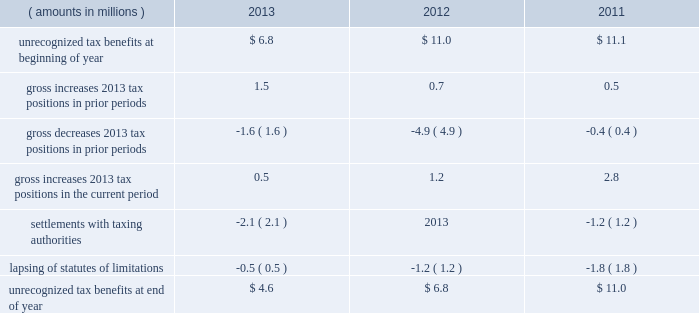A valuation allowance totaling $ 45.4 million , $ 43.9 million and $ 40.4 million as of 2013 , 2012 and 2011 year end , respectively , has been established for deferred income tax assets primarily related to certain subsidiary loss carryforwards that may not be realized .
Realization of the net deferred income tax assets is dependent on generating sufficient taxable income prior to their expiration .
Although realization is not assured , management believes it is more- likely-than-not that the net deferred income tax assets will be realized .
The amount of the net deferred income tax assets considered realizable , however , could change in the near term if estimates of future taxable income during the carryforward period fluctuate .
The following is a reconciliation of the beginning and ending amounts of unrecognized tax benefits for 2013 , 2012 and ( amounts in millions ) 2013 2012 2011 .
Of the $ 4.6 million , $ 6.8 million and $ 11.0 million of unrecognized tax benefits as of 2013 , 2012 and 2011 year end , respectively , approximately $ 4.6 million , $ 4.1 million and $ 9.1 million , respectively , would impact the effective income tax rate if recognized .
Interest and penalties related to unrecognized tax benefits are recorded in income tax expense .
During 2013 and 2012 , the company reversed a net $ 0.6 million and $ 0.5 million , respectively , of interest and penalties to income associated with unrecognized tax benefits .
As of 2013 , 2012 and 2011 year end , the company has provided for $ 0.9 million , $ 1.6 million and $ 1.6 million , respectively , of accrued interest and penalties related to unrecognized tax benefits .
The unrecognized tax benefits and related accrued interest and penalties are included in 201cother long-term liabilities 201d on the accompanying consolidated balance sheets .
Snap-on and its subsidiaries file income tax returns in the united states and in various state , local and foreign jurisdictions .
It is reasonably possible that certain unrecognized tax benefits may either be settled with taxing authorities or the statutes of limitations for such items may lapse within the next 12 months , causing snap-on 2019s gross unrecognized tax benefits to decrease by a range of zero to $ 1.1 million .
Over the next 12 months , snap-on anticipates taking certain tax positions on various tax returns for which the related tax benefit does not meet the recognition threshold .
Accordingly , snap-on 2019s gross unrecognized tax benefits may increase by a range of zero to $ 0.8 million over the next 12 months for uncertain tax positions expected to be taken in future tax filings .
With few exceptions , snap-on is no longer subject to u.s .
Federal and state/local income tax examinations by tax authorities for years prior to 2008 , and snap-on is no longer subject to non-u.s .
Income tax examinations by tax authorities for years prior to 2006 .
The undistributed earnings of all non-u.s .
Subsidiaries totaled $ 556.0 million , $ 492.2 million and $ 416.4 million as of 2013 , 2012 and 2011 year end , respectively .
Snap-on has not provided any deferred taxes on these undistributed earnings as it considers the undistributed earnings to be permanently invested .
Determination of the amount of unrecognized deferred income tax liability related to these earnings is not practicable .
2013 annual report 83 .
What is the net change amount in the unrecognized tax benefits during 2012? 
Computations: (6.8 - 11.0)
Answer: -4.2. A valuation allowance totaling $ 45.4 million , $ 43.9 million and $ 40.4 million as of 2013 , 2012 and 2011 year end , respectively , has been established for deferred income tax assets primarily related to certain subsidiary loss carryforwards that may not be realized .
Realization of the net deferred income tax assets is dependent on generating sufficient taxable income prior to their expiration .
Although realization is not assured , management believes it is more- likely-than-not that the net deferred income tax assets will be realized .
The amount of the net deferred income tax assets considered realizable , however , could change in the near term if estimates of future taxable income during the carryforward period fluctuate .
The following is a reconciliation of the beginning and ending amounts of unrecognized tax benefits for 2013 , 2012 and ( amounts in millions ) 2013 2012 2011 .
Of the $ 4.6 million , $ 6.8 million and $ 11.0 million of unrecognized tax benefits as of 2013 , 2012 and 2011 year end , respectively , approximately $ 4.6 million , $ 4.1 million and $ 9.1 million , respectively , would impact the effective income tax rate if recognized .
Interest and penalties related to unrecognized tax benefits are recorded in income tax expense .
During 2013 and 2012 , the company reversed a net $ 0.6 million and $ 0.5 million , respectively , of interest and penalties to income associated with unrecognized tax benefits .
As of 2013 , 2012 and 2011 year end , the company has provided for $ 0.9 million , $ 1.6 million and $ 1.6 million , respectively , of accrued interest and penalties related to unrecognized tax benefits .
The unrecognized tax benefits and related accrued interest and penalties are included in 201cother long-term liabilities 201d on the accompanying consolidated balance sheets .
Snap-on and its subsidiaries file income tax returns in the united states and in various state , local and foreign jurisdictions .
It is reasonably possible that certain unrecognized tax benefits may either be settled with taxing authorities or the statutes of limitations for such items may lapse within the next 12 months , causing snap-on 2019s gross unrecognized tax benefits to decrease by a range of zero to $ 1.1 million .
Over the next 12 months , snap-on anticipates taking certain tax positions on various tax returns for which the related tax benefit does not meet the recognition threshold .
Accordingly , snap-on 2019s gross unrecognized tax benefits may increase by a range of zero to $ 0.8 million over the next 12 months for uncertain tax positions expected to be taken in future tax filings .
With few exceptions , snap-on is no longer subject to u.s .
Federal and state/local income tax examinations by tax authorities for years prior to 2008 , and snap-on is no longer subject to non-u.s .
Income tax examinations by tax authorities for years prior to 2006 .
The undistributed earnings of all non-u.s .
Subsidiaries totaled $ 556.0 million , $ 492.2 million and $ 416.4 million as of 2013 , 2012 and 2011 year end , respectively .
Snap-on has not provided any deferred taxes on these undistributed earnings as it considers the undistributed earnings to be permanently invested .
Determination of the amount of unrecognized deferred income tax liability related to these earnings is not practicable .
2013 annual report 83 .
In 2013 what was the percent of the unrecognized income tax benefit that could impact effective income tax rate if recognized? 
Computations: (4.1 / 4.6)
Answer: 0.8913. 